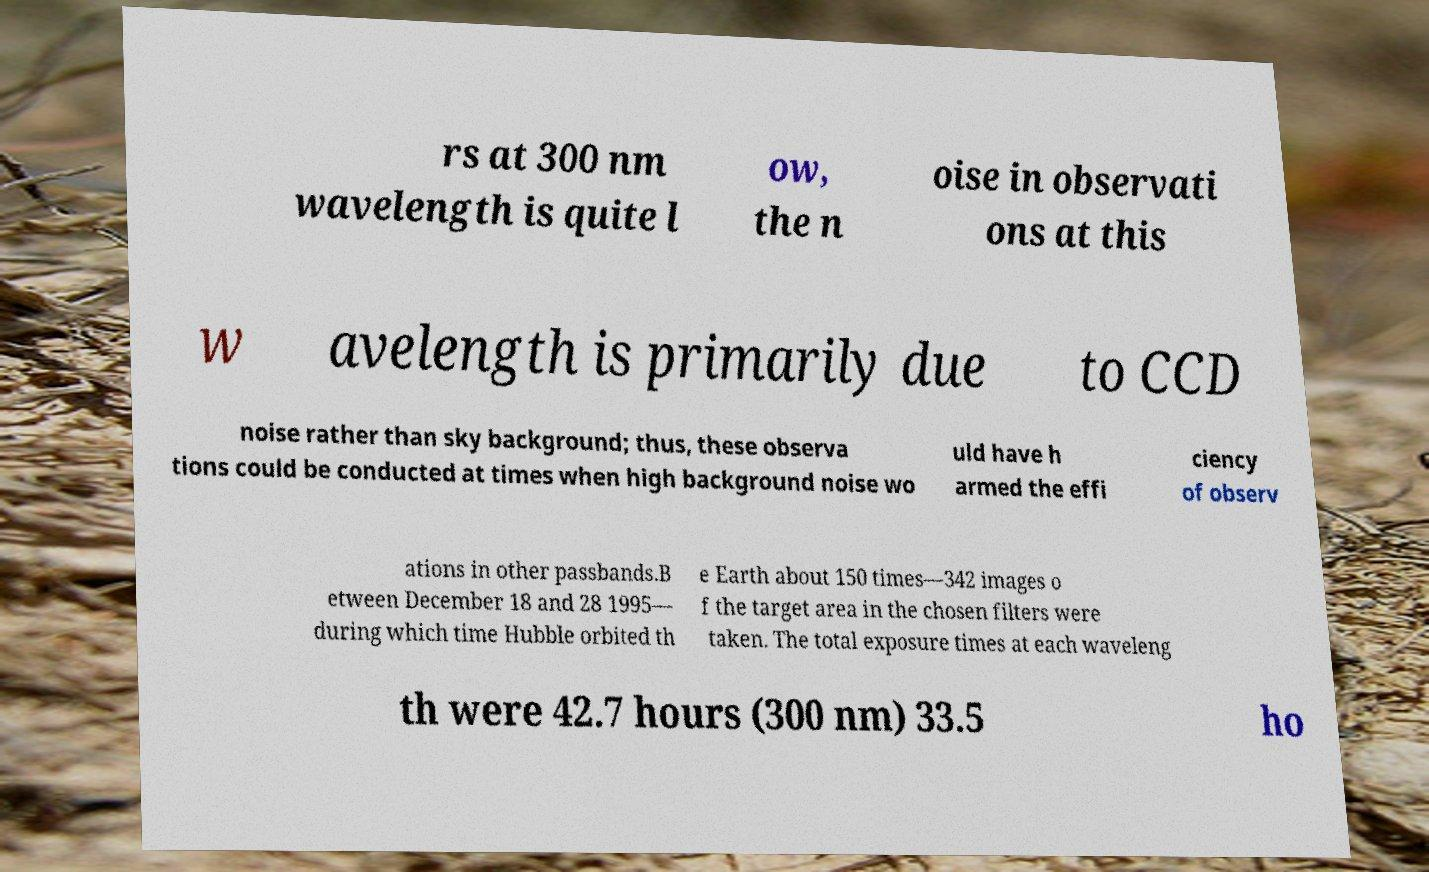Could you assist in decoding the text presented in this image and type it out clearly? rs at 300 nm wavelength is quite l ow, the n oise in observati ons at this w avelength is primarily due to CCD noise rather than sky background; thus, these observa tions could be conducted at times when high background noise wo uld have h armed the effi ciency of observ ations in other passbands.B etween December 18 and 28 1995— during which time Hubble orbited th e Earth about 150 times—342 images o f the target area in the chosen filters were taken. The total exposure times at each waveleng th were 42.7 hours (300 nm) 33.5 ho 